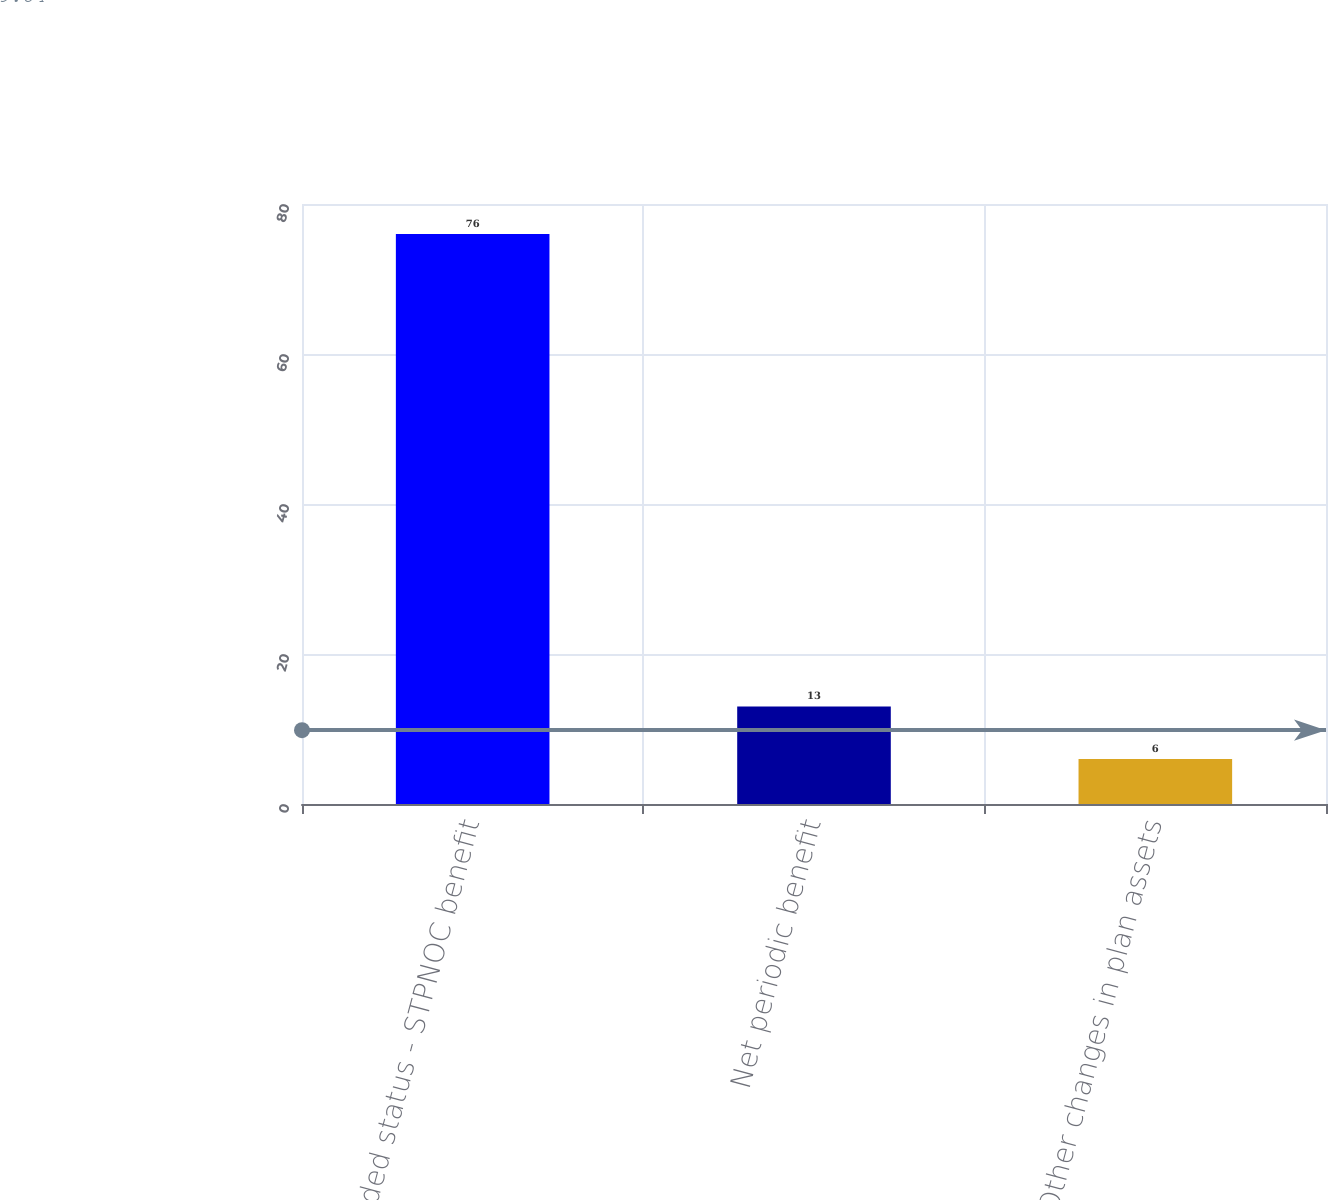<chart> <loc_0><loc_0><loc_500><loc_500><bar_chart><fcel>Funded status - STPNOC benefit<fcel>Net periodic benefit<fcel>Other changes in plan assets<nl><fcel>76<fcel>13<fcel>6<nl></chart> 